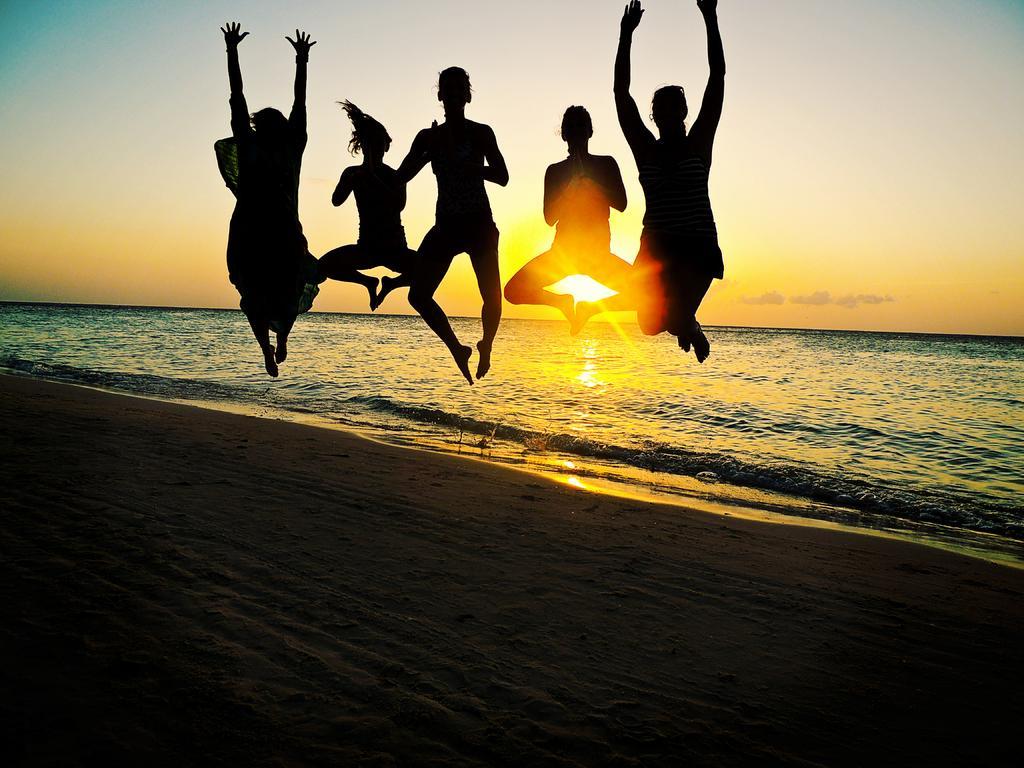In one or two sentences, can you explain what this image depicts? In this image we can see few people posing for a photo and we can see the ocean. In the background, we can see the sky and the sun. 